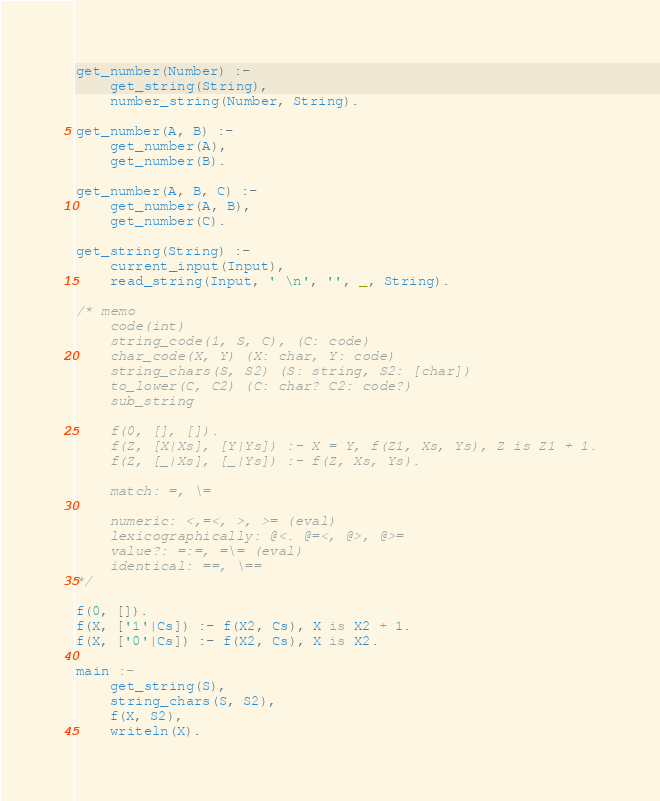Convert code to text. <code><loc_0><loc_0><loc_500><loc_500><_Prolog_>get_number(Number) :-
    get_string(String),
    number_string(Number, String).

get_number(A, B) :-
    get_number(A),
    get_number(B).

get_number(A, B, C) :-
    get_number(A, B),
    get_number(C).

get_string(String) :-
    current_input(Input),
    read_string(Input, ' \n', '', _, String).

/* memo
    code(int)
    string_code(1, S, C), (C: code)
    char_code(X, Y) (X: char, Y: code)
    string_chars(S, S2) (S: string, S2: [char])
    to_lower(C, C2) (C: char? C2: code?)
    sub_string

    f(0, [], []).
    f(Z, [X|Xs], [Y|Ys]) :- X = Y, f(Z1, Xs, Ys), Z is Z1 + 1.
    f(Z, [_|Xs], [_|Ys]) :- f(Z, Xs, Ys).

    match: =, \=

    numeric: <,=<, >, >= (eval)
    lexicographically: @<. @=<, @>, @>=
    value?: =:=, =\= (eval)
    identical: ==, \==
*/

f(0, []).
f(X, ['1'|Cs]) :- f(X2, Cs), X is X2 + 1.
f(X, ['0'|Cs]) :- f(X2, Cs), X is X2.

main :-
    get_string(S),
    string_chars(S, S2),
    f(X, S2),
    writeln(X).
</code> 